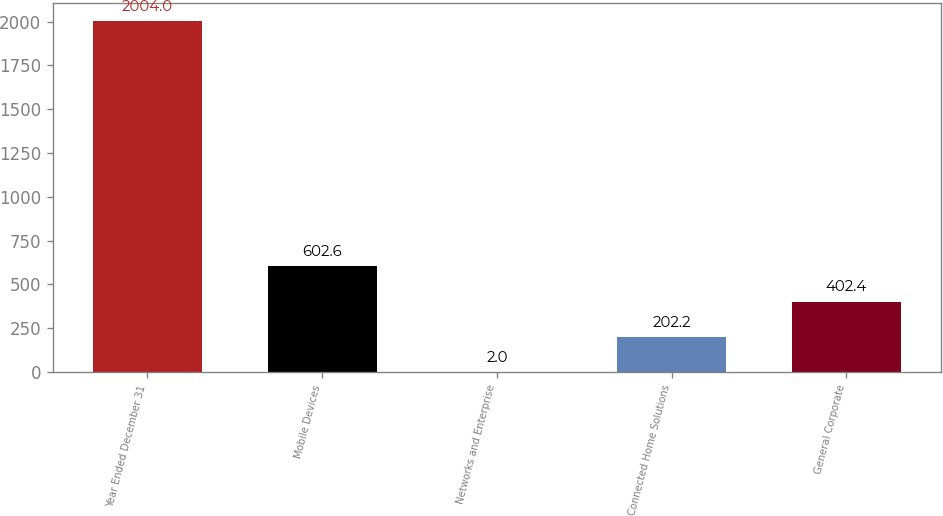<chart> <loc_0><loc_0><loc_500><loc_500><bar_chart><fcel>Year Ended December 31<fcel>Mobile Devices<fcel>Networks and Enterprise<fcel>Connected Home Solutions<fcel>General Corporate<nl><fcel>2004<fcel>602.6<fcel>2<fcel>202.2<fcel>402.4<nl></chart> 